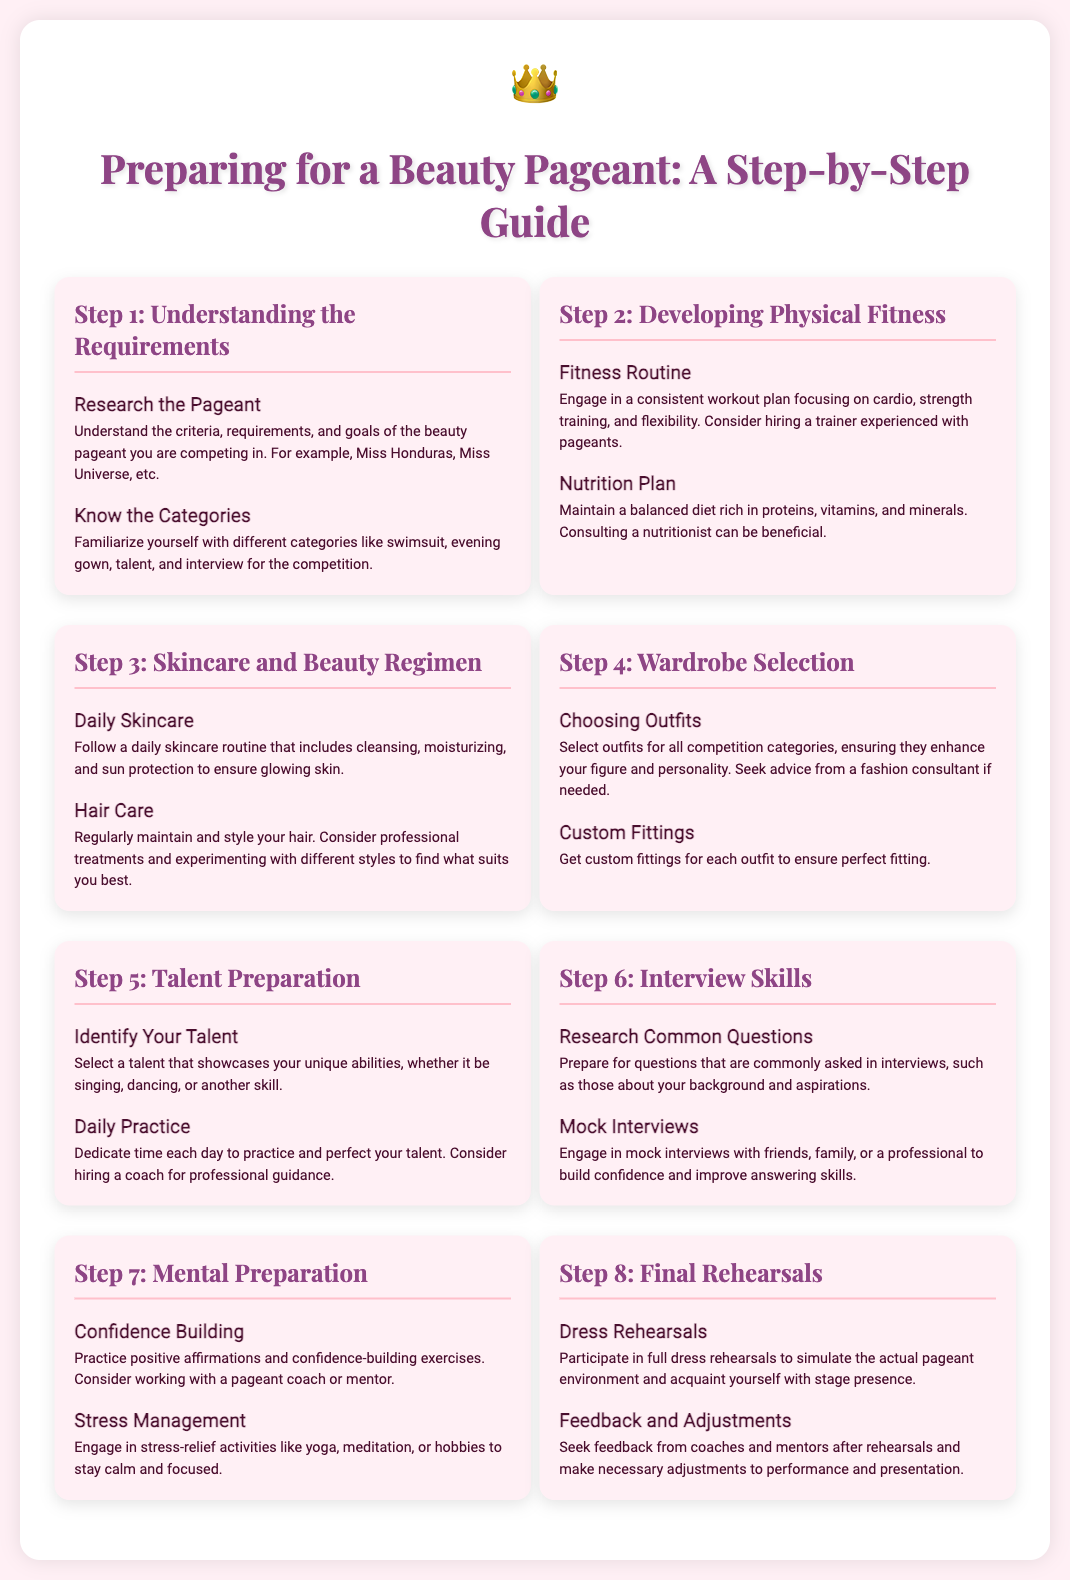What is the first step in preparing for a beauty pageant? The first step is to understand the requirements of the beauty pageant, including criteria and goals.
Answer: Understanding the Requirements What is included in the fitness routine? The fitness routine should include cardio, strength training, and flexibility exercises for physical fitness.
Answer: Fitness Routine How should one maintain skin? Following a daily skincare routine that includes cleansing, moisturizing, and sun protection is essential for skincare.
Answer: Daily Skincare What talent preparation involves choosing? Choosing a talent that showcases your unique abilities is crucial for talent preparation.
Answer: Identify Your Talent What do mock interviews help with? Mock interviews help build confidence and improve answering skills for interviews.
Answer: Mock Interviews What is the purpose of dress rehearsals? Dress rehearsals simulate the actual pageant environment and help acclimate participants to stage presence.
Answer: Dress Rehearsals How can stress be managed during preparation? Engaging in stress-relief activities like yoga and meditation helps with stress management.
Answer: Stress Management What is a suggested activity for confidence building? Practicing positive affirmations is a suggested activity for building confidence.
Answer: Confidence Building What is required for custom fittings? Custom fittings are required for each outfit to ensure perfect fitting.
Answer: Custom Fittings 